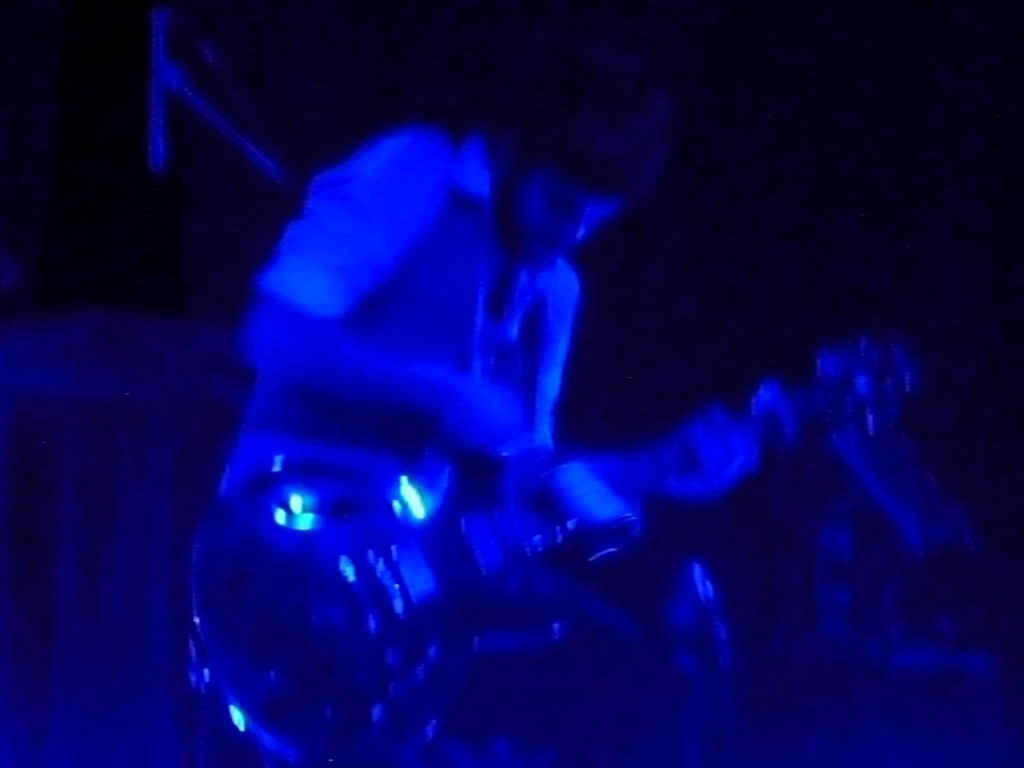With such lighting conditions, what challenges does a photographer face, and how can they address them? In these conditions, a photographer deals with low light and fast-moving subjects, making it difficult to capture crisp images. To address this, they may use a higher ISO setting, a wider aperture, or slower shutter speed to allow more light onto the camera sensor. However, each of these adjustments comes with trade-offs, like increased noise with high ISO or motion blur with a slower shutter speed, which can be used creatively to enhance the mood. 